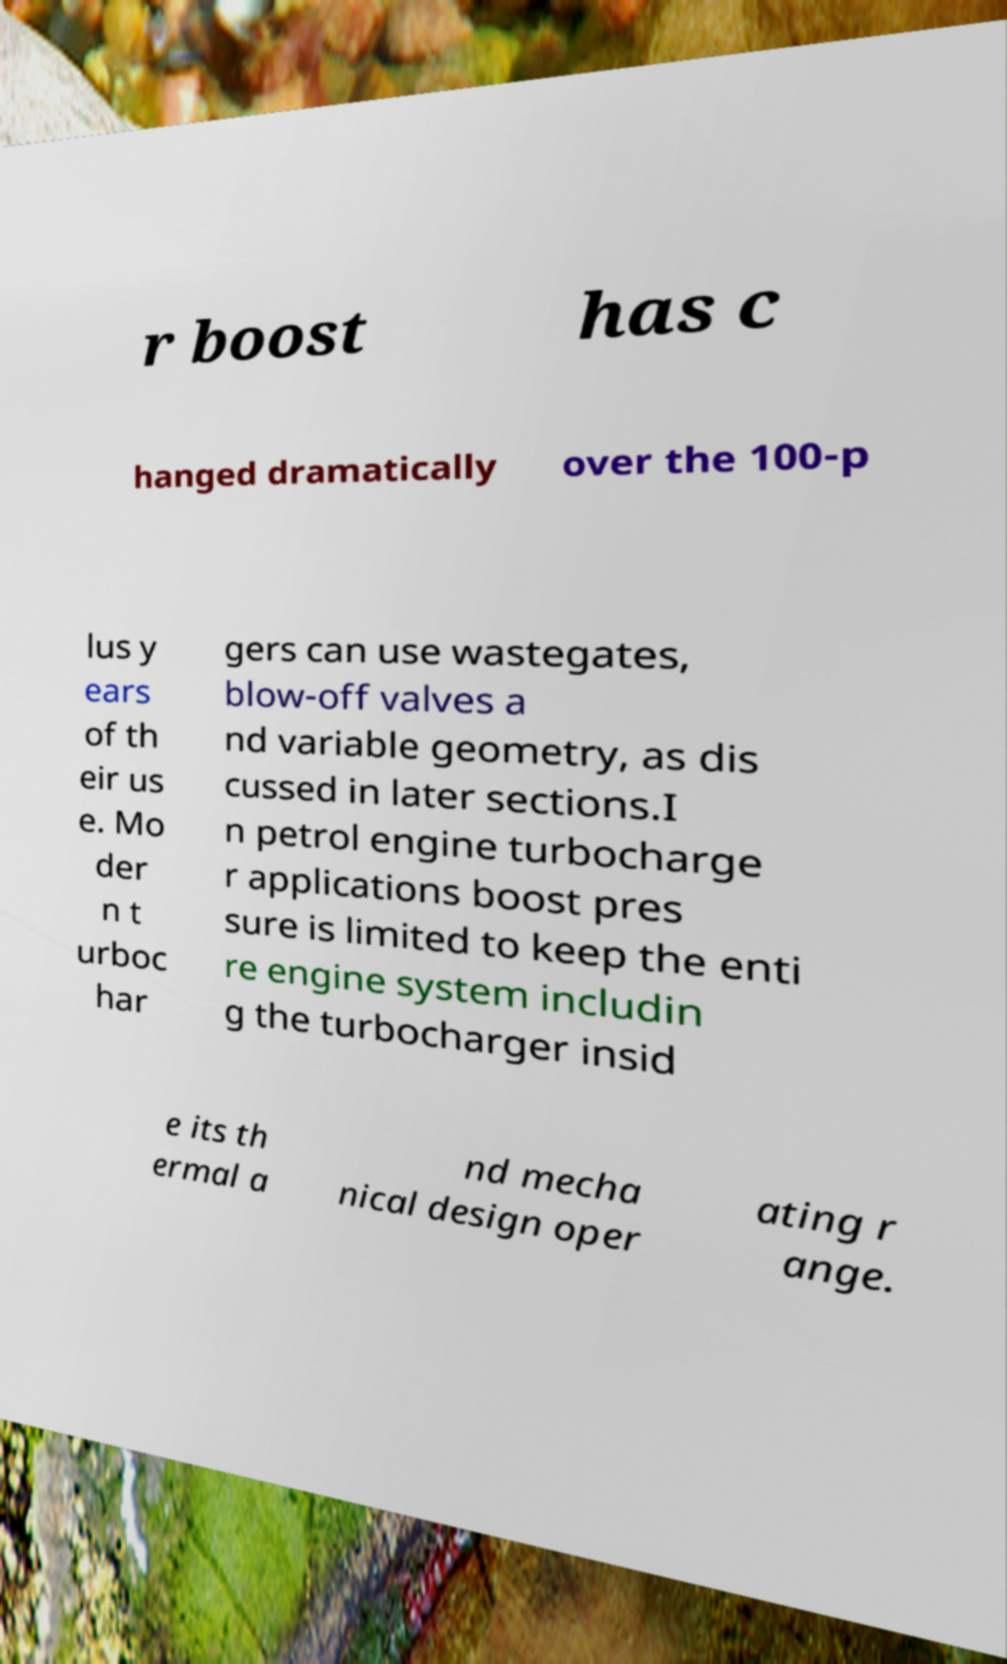Could you extract and type out the text from this image? r boost has c hanged dramatically over the 100-p lus y ears of th eir us e. Mo der n t urboc har gers can use wastegates, blow-off valves a nd variable geometry, as dis cussed in later sections.I n petrol engine turbocharge r applications boost pres sure is limited to keep the enti re engine system includin g the turbocharger insid e its th ermal a nd mecha nical design oper ating r ange. 